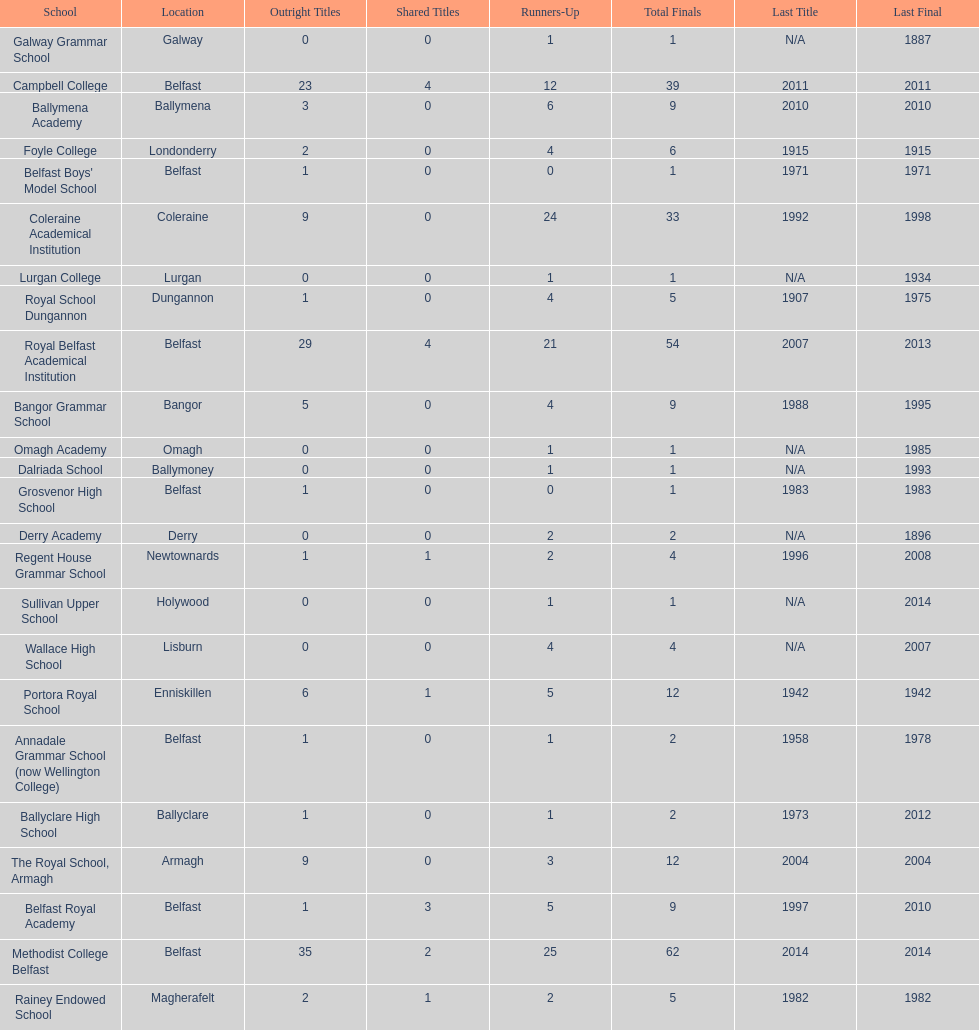Did belfast royal academy have more or less total finals than ballyclare high school? More. 